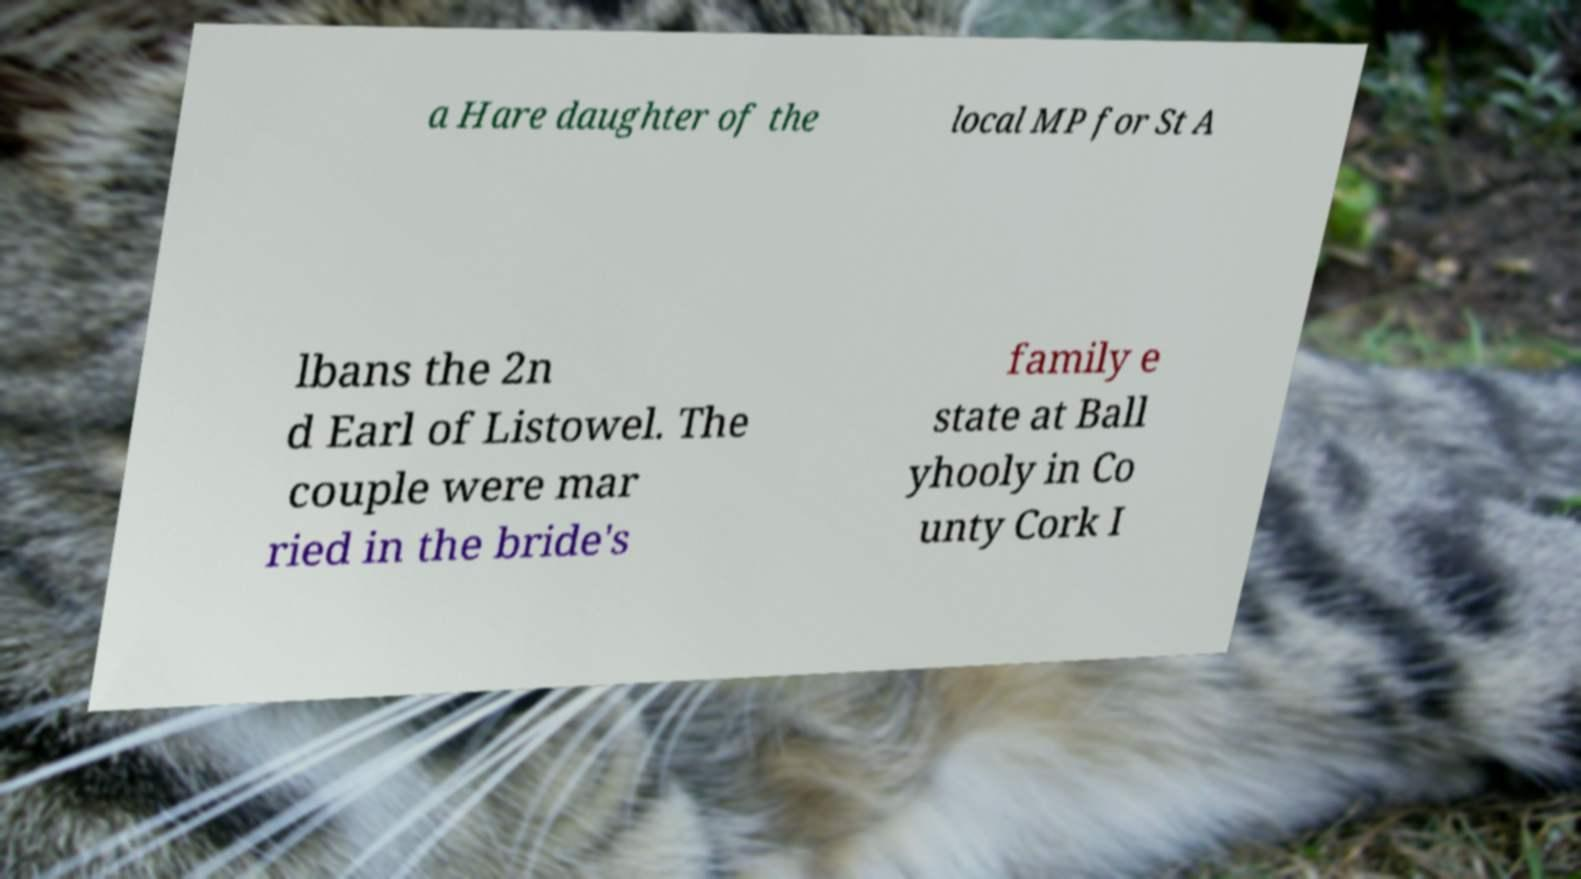What messages or text are displayed in this image? I need them in a readable, typed format. a Hare daughter of the local MP for St A lbans the 2n d Earl of Listowel. The couple were mar ried in the bride's family e state at Ball yhooly in Co unty Cork I 